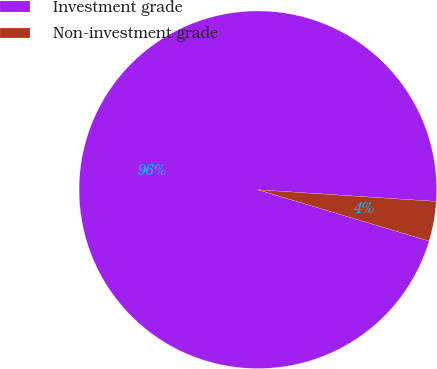Convert chart. <chart><loc_0><loc_0><loc_500><loc_500><pie_chart><fcel>Investment grade<fcel>Non-investment grade<nl><fcel>96.41%<fcel>3.59%<nl></chart> 